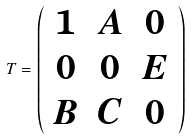Convert formula to latex. <formula><loc_0><loc_0><loc_500><loc_500>T = \left ( \begin{array} { c c c } 1 & A & 0 \\ 0 & 0 & E \\ B & C & 0 \\ \end{array} \right )</formula> 